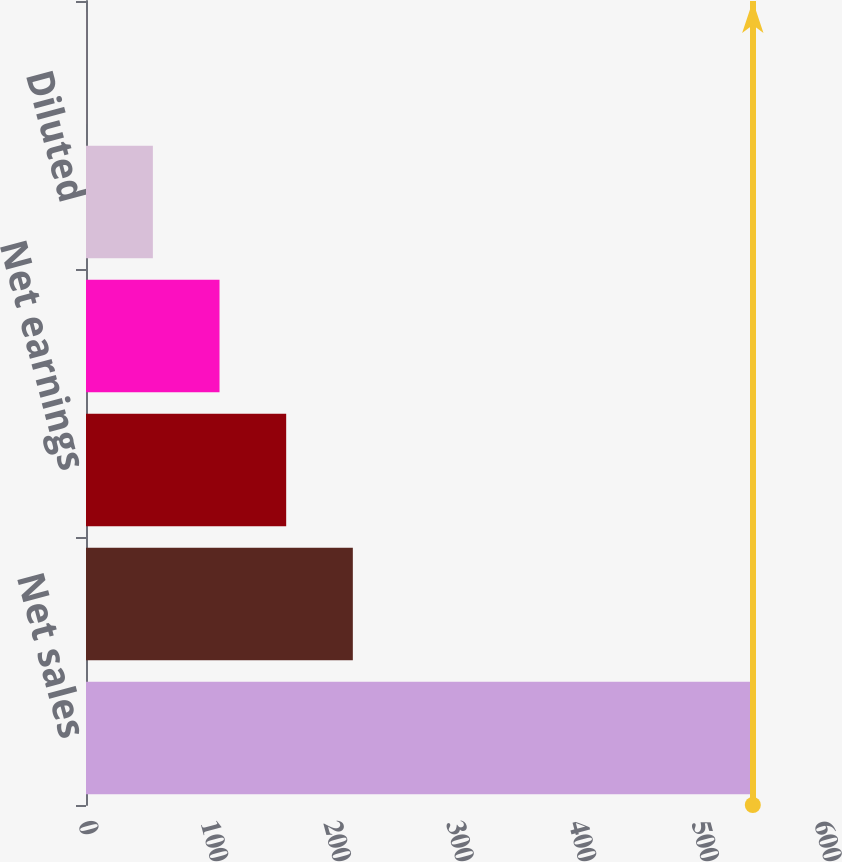<chart> <loc_0><loc_0><loc_500><loc_500><bar_chart><fcel>Net sales<fcel>Gross profit<fcel>Net earnings<fcel>Basic<fcel>Diluted<fcel>Common dividends declared<nl><fcel>543.6<fcel>217.53<fcel>163.19<fcel>108.85<fcel>54.51<fcel>0.17<nl></chart> 